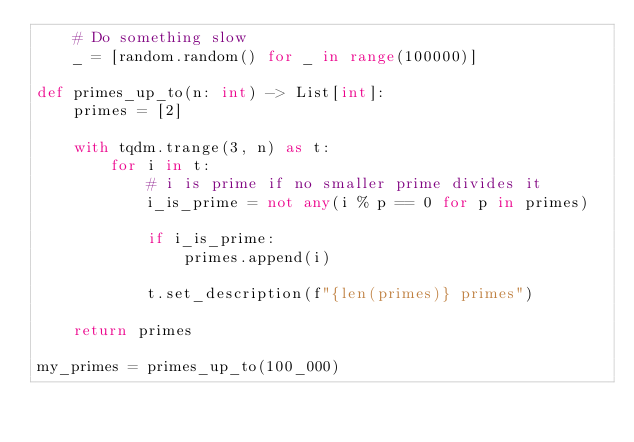<code> <loc_0><loc_0><loc_500><loc_500><_Python_>    # Do something slow
    _ = [random.random() for _ in range(100000)]

def primes_up_to(n: int) -> List[int]:
    primes = [2]

    with tqdm.trange(3, n) as t:
        for i in t:
            # i is prime if no smaller prime divides it
            i_is_prime = not any(i % p == 0 for p in primes)

            if i_is_prime:
                primes.append(i)

            t.set_description(f"{len(primes)} primes")
    
    return primes

my_primes = primes_up_to(100_000)</code> 